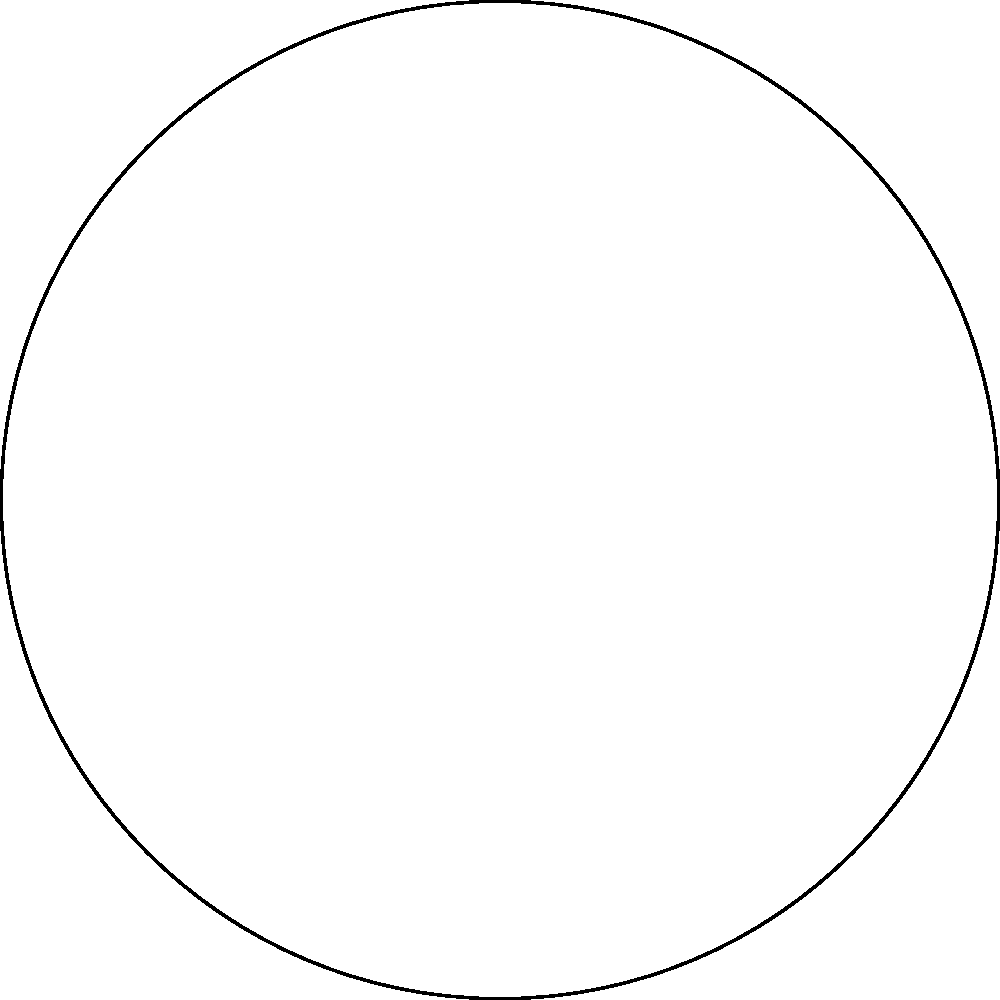Logan's population growth over the past decade can be represented by a sector in a circle. If the central angle of this sector is 108°, and the radius of the circle representing the total possible growth is 15 km (symbolizing the city's expansion limit), what is the area of the sector representing Logan's actual growth? To solve this problem, we need to follow these steps:

1) The formula for the area of a sector is:
   $$A = \frac{\theta}{360°} \pi r^2$$
   where $\theta$ is the central angle in degrees, and $r$ is the radius.

2) We are given:
   $\theta = 108°$
   $r = 15$ km

3) Let's substitute these values into our formula:
   $$A = \frac{108°}{360°} \pi (15 \text{ km})^2$$

4) Simplify:
   $$A = 0.3 \pi (225 \text{ km}^2)$$
   $$A = 67.5\pi \text{ km}^2$$

5) If we want to calculate the exact value:
   $$A \approx 212.06 \text{ km}^2$$

Therefore, the area of the sector representing Logan's population growth is $67.5\pi$ square kilometers or approximately 212.06 square kilometers.
Answer: $67.5\pi \text{ km}^2$ or approximately 212.06 km² 